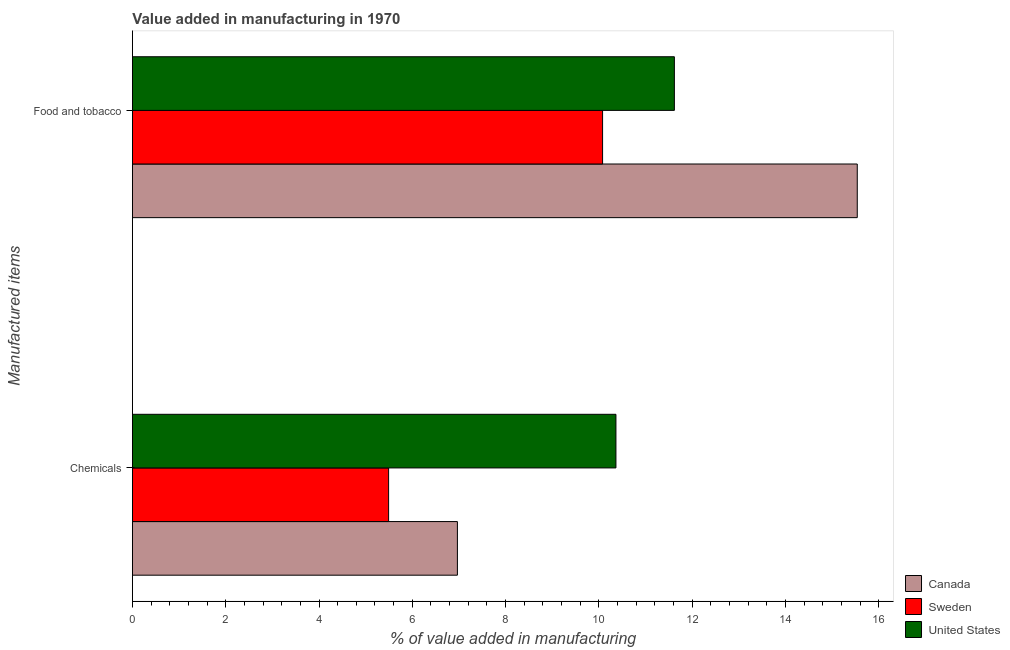What is the label of the 2nd group of bars from the top?
Your response must be concise. Chemicals. What is the value added by manufacturing food and tobacco in Canada?
Your response must be concise. 15.54. Across all countries, what is the maximum value added by manufacturing food and tobacco?
Give a very brief answer. 15.54. Across all countries, what is the minimum value added by  manufacturing chemicals?
Your answer should be compact. 5.49. In which country was the value added by manufacturing food and tobacco maximum?
Your answer should be very brief. Canada. What is the total value added by manufacturing food and tobacco in the graph?
Give a very brief answer. 37.24. What is the difference between the value added by  manufacturing chemicals in Sweden and that in Canada?
Your response must be concise. -1.48. What is the difference between the value added by manufacturing food and tobacco in Canada and the value added by  manufacturing chemicals in Sweden?
Provide a succinct answer. 10.05. What is the average value added by  manufacturing chemicals per country?
Provide a short and direct response. 7.61. What is the difference between the value added by manufacturing food and tobacco and value added by  manufacturing chemicals in United States?
Offer a very short reply. 1.25. What is the ratio of the value added by manufacturing food and tobacco in Canada to that in Sweden?
Your response must be concise. 1.54. What does the 3rd bar from the top in Food and tobacco represents?
Your answer should be compact. Canada. What does the 3rd bar from the bottom in Food and tobacco represents?
Provide a succinct answer. United States. How many bars are there?
Offer a very short reply. 6. How many countries are there in the graph?
Offer a terse response. 3. Are the values on the major ticks of X-axis written in scientific E-notation?
Your response must be concise. No. Where does the legend appear in the graph?
Make the answer very short. Bottom right. How many legend labels are there?
Offer a very short reply. 3. What is the title of the graph?
Your answer should be compact. Value added in manufacturing in 1970. Does "Maldives" appear as one of the legend labels in the graph?
Provide a succinct answer. No. What is the label or title of the X-axis?
Offer a terse response. % of value added in manufacturing. What is the label or title of the Y-axis?
Offer a very short reply. Manufactured items. What is the % of value added in manufacturing of Canada in Chemicals?
Your response must be concise. 6.97. What is the % of value added in manufacturing in Sweden in Chemicals?
Your response must be concise. 5.49. What is the % of value added in manufacturing of United States in Chemicals?
Provide a succinct answer. 10.37. What is the % of value added in manufacturing of Canada in Food and tobacco?
Give a very brief answer. 15.54. What is the % of value added in manufacturing in Sweden in Food and tobacco?
Your response must be concise. 10.08. What is the % of value added in manufacturing of United States in Food and tobacco?
Your answer should be very brief. 11.62. Across all Manufactured items, what is the maximum % of value added in manufacturing in Canada?
Ensure brevity in your answer.  15.54. Across all Manufactured items, what is the maximum % of value added in manufacturing of Sweden?
Keep it short and to the point. 10.08. Across all Manufactured items, what is the maximum % of value added in manufacturing of United States?
Your answer should be compact. 11.62. Across all Manufactured items, what is the minimum % of value added in manufacturing of Canada?
Provide a succinct answer. 6.97. Across all Manufactured items, what is the minimum % of value added in manufacturing in Sweden?
Your answer should be very brief. 5.49. Across all Manufactured items, what is the minimum % of value added in manufacturing of United States?
Offer a very short reply. 10.37. What is the total % of value added in manufacturing in Canada in the graph?
Give a very brief answer. 22.51. What is the total % of value added in manufacturing in Sweden in the graph?
Your answer should be compact. 15.57. What is the total % of value added in manufacturing of United States in the graph?
Provide a short and direct response. 21.99. What is the difference between the % of value added in manufacturing of Canada in Chemicals and that in Food and tobacco?
Your answer should be very brief. -8.57. What is the difference between the % of value added in manufacturing of Sweden in Chemicals and that in Food and tobacco?
Ensure brevity in your answer.  -4.59. What is the difference between the % of value added in manufacturing in United States in Chemicals and that in Food and tobacco?
Give a very brief answer. -1.25. What is the difference between the % of value added in manufacturing of Canada in Chemicals and the % of value added in manufacturing of Sweden in Food and tobacco?
Ensure brevity in your answer.  -3.11. What is the difference between the % of value added in manufacturing in Canada in Chemicals and the % of value added in manufacturing in United States in Food and tobacco?
Your answer should be compact. -4.65. What is the difference between the % of value added in manufacturing in Sweden in Chemicals and the % of value added in manufacturing in United States in Food and tobacco?
Make the answer very short. -6.13. What is the average % of value added in manufacturing of Canada per Manufactured items?
Your answer should be very brief. 11.25. What is the average % of value added in manufacturing in Sweden per Manufactured items?
Your answer should be compact. 7.79. What is the average % of value added in manufacturing in United States per Manufactured items?
Your response must be concise. 10.99. What is the difference between the % of value added in manufacturing in Canada and % of value added in manufacturing in Sweden in Chemicals?
Ensure brevity in your answer.  1.48. What is the difference between the % of value added in manufacturing in Canada and % of value added in manufacturing in United States in Chemicals?
Ensure brevity in your answer.  -3.4. What is the difference between the % of value added in manufacturing of Sweden and % of value added in manufacturing of United States in Chemicals?
Offer a very short reply. -4.87. What is the difference between the % of value added in manufacturing of Canada and % of value added in manufacturing of Sweden in Food and tobacco?
Offer a very short reply. 5.46. What is the difference between the % of value added in manufacturing in Canada and % of value added in manufacturing in United States in Food and tobacco?
Offer a very short reply. 3.92. What is the difference between the % of value added in manufacturing of Sweden and % of value added in manufacturing of United States in Food and tobacco?
Ensure brevity in your answer.  -1.54. What is the ratio of the % of value added in manufacturing of Canada in Chemicals to that in Food and tobacco?
Keep it short and to the point. 0.45. What is the ratio of the % of value added in manufacturing of Sweden in Chemicals to that in Food and tobacco?
Make the answer very short. 0.54. What is the ratio of the % of value added in manufacturing of United States in Chemicals to that in Food and tobacco?
Your answer should be very brief. 0.89. What is the difference between the highest and the second highest % of value added in manufacturing of Canada?
Keep it short and to the point. 8.57. What is the difference between the highest and the second highest % of value added in manufacturing in Sweden?
Offer a very short reply. 4.59. What is the difference between the highest and the second highest % of value added in manufacturing of United States?
Make the answer very short. 1.25. What is the difference between the highest and the lowest % of value added in manufacturing in Canada?
Provide a short and direct response. 8.57. What is the difference between the highest and the lowest % of value added in manufacturing of Sweden?
Provide a succinct answer. 4.59. What is the difference between the highest and the lowest % of value added in manufacturing in United States?
Provide a succinct answer. 1.25. 